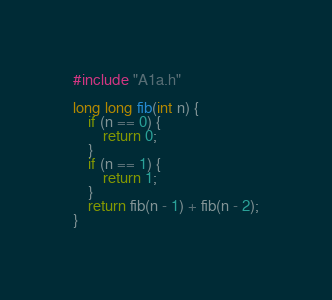Convert code to text. <code><loc_0><loc_0><loc_500><loc_500><_C_>#include "A1a.h"

long long fib(int n) {
    if (n == 0) {
        return 0;
    }
    if (n == 1) {
        return 1;
    }
    return fib(n - 1) + fib(n - 2);
}
</code> 